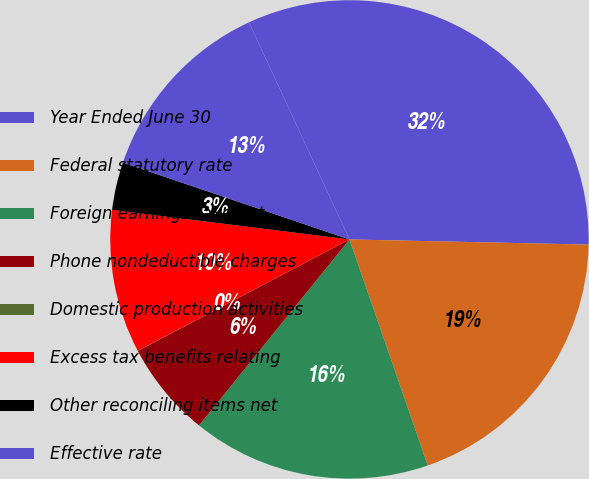<chart> <loc_0><loc_0><loc_500><loc_500><pie_chart><fcel>Year Ended June 30<fcel>Federal statutory rate<fcel>Foreign earnings taxed at<fcel>Phone nondeductible charges<fcel>Domestic production activities<fcel>Excess tax benefits relating<fcel>Other reconciling items net<fcel>Effective rate<nl><fcel>32.24%<fcel>19.35%<fcel>16.13%<fcel>6.46%<fcel>0.01%<fcel>9.68%<fcel>3.23%<fcel>12.9%<nl></chart> 